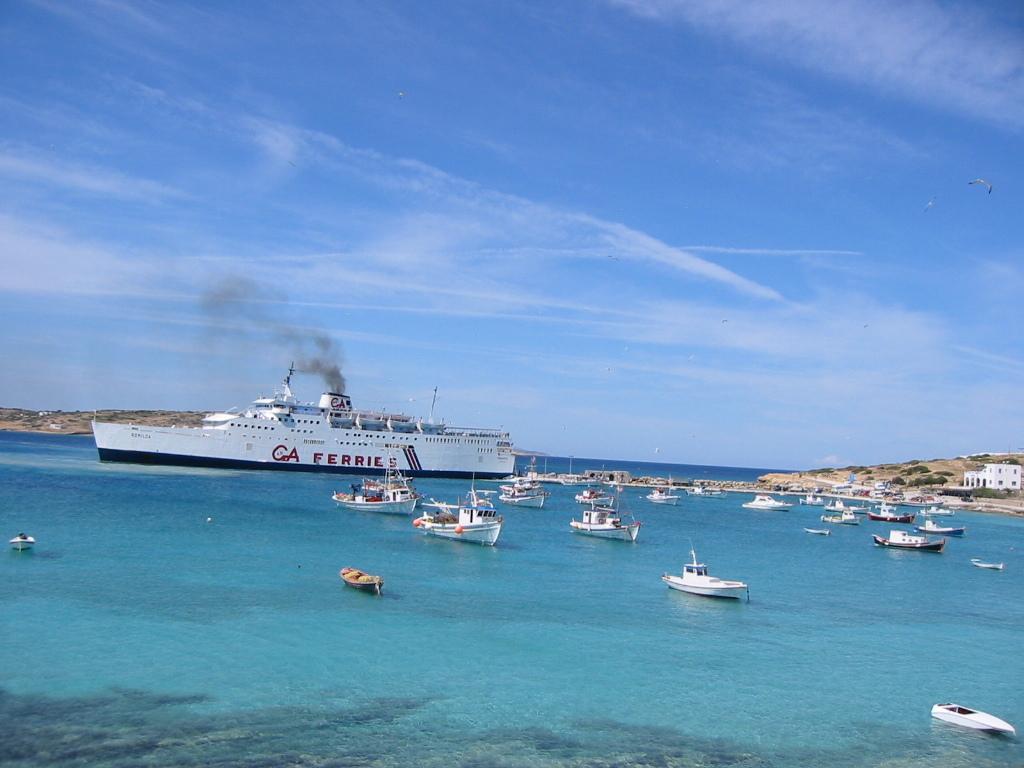In one or two sentences, can you explain what this image depicts? In this image, we can see ships sailing in the water. We can also see hills and plants on it. We can see a building on the right side. We can also see the sky. 